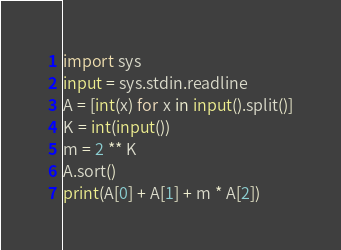Convert code to text. <code><loc_0><loc_0><loc_500><loc_500><_Python_>import sys
input = sys.stdin.readline
A = [int(x) for x in input().split()]
K = int(input())
m = 2 ** K
A.sort()
print(A[0] + A[1] + m * A[2])</code> 